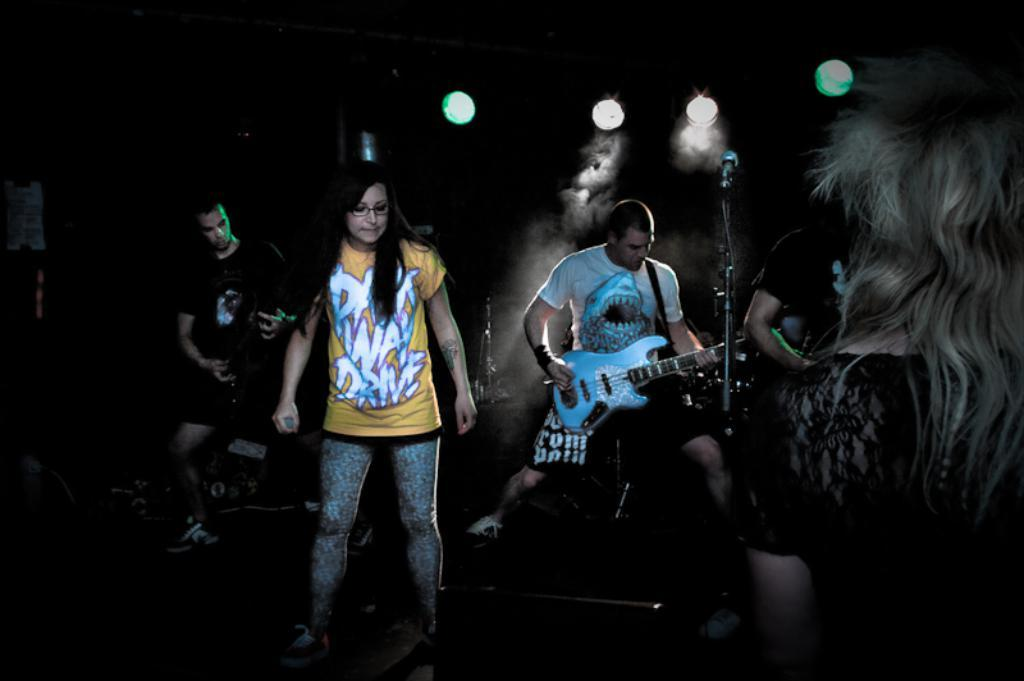How many people are in the image? There are three people in the image. What are two of the people doing in the image? Two of the people are playing the guitar. What is the third person holding in her right hand? The third person is holding a microphone in her right hand. What can be seen attached to the ceiling in the image? Disco lights are attached to the ceiling. What type of prose is being recited by the person holding the microphone? There is no indication in the image that the person holding the microphone is reciting any prose. Can you see any sheets in the image? There are no sheets visible in the image. 